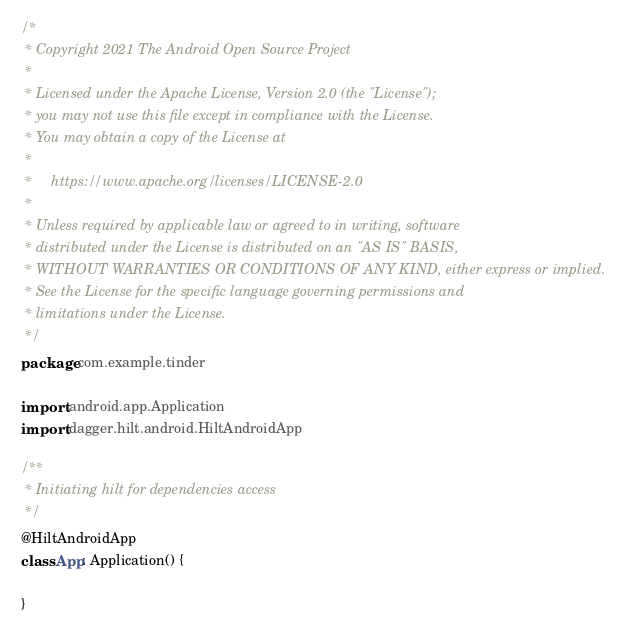<code> <loc_0><loc_0><loc_500><loc_500><_Kotlin_>/*
 * Copyright 2021 The Android Open Source Project
 *
 * Licensed under the Apache License, Version 2.0 (the "License");
 * you may not use this file except in compliance with the License.
 * You may obtain a copy of the License at
 *
 *     https://www.apache.org/licenses/LICENSE-2.0
 *
 * Unless required by applicable law or agreed to in writing, software
 * distributed under the License is distributed on an "AS IS" BASIS,
 * WITHOUT WARRANTIES OR CONDITIONS OF ANY KIND, either express or implied.
 * See the License for the specific language governing permissions and
 * limitations under the License.
 */
package com.example.tinder

import android.app.Application
import dagger.hilt.android.HiltAndroidApp

/**
 * Initiating hilt for dependencies access
 */
@HiltAndroidApp
class App: Application() {

}</code> 